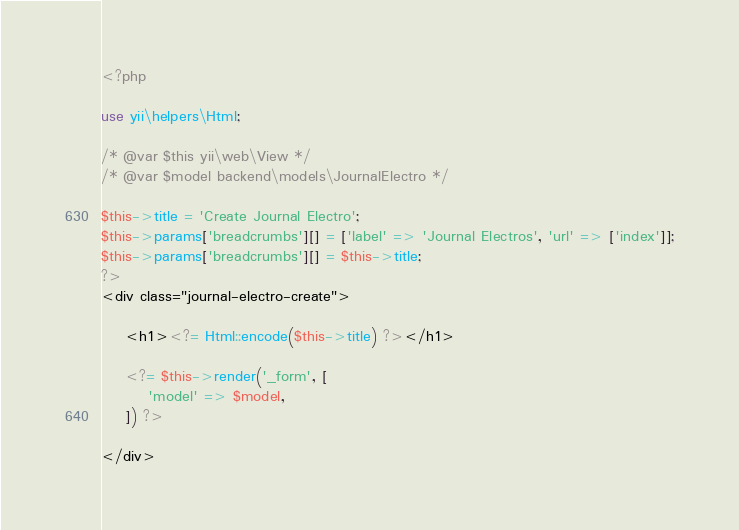<code> <loc_0><loc_0><loc_500><loc_500><_PHP_><?php

use yii\helpers\Html;

/* @var $this yii\web\View */
/* @var $model backend\models\JournalElectro */

$this->title = 'Create Journal Electro';
$this->params['breadcrumbs'][] = ['label' => 'Journal Electros', 'url' => ['index']];
$this->params['breadcrumbs'][] = $this->title;
?>
<div class="journal-electro-create">

    <h1><?= Html::encode($this->title) ?></h1>

    <?= $this->render('_form', [
        'model' => $model,
    ]) ?>

</div>
</code> 